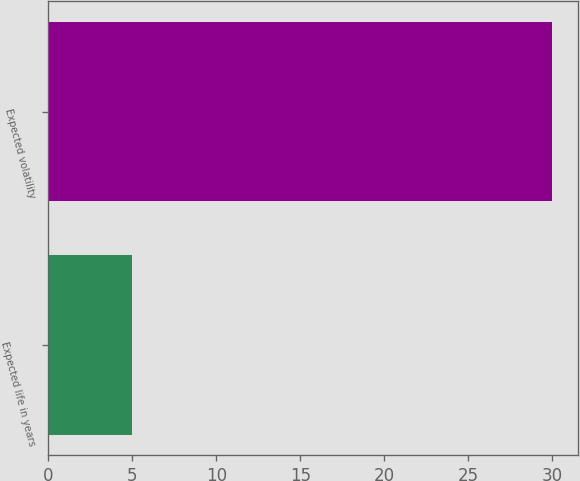Convert chart. <chart><loc_0><loc_0><loc_500><loc_500><bar_chart><fcel>Expected life in years<fcel>Expected volatility<nl><fcel>5<fcel>30<nl></chart> 